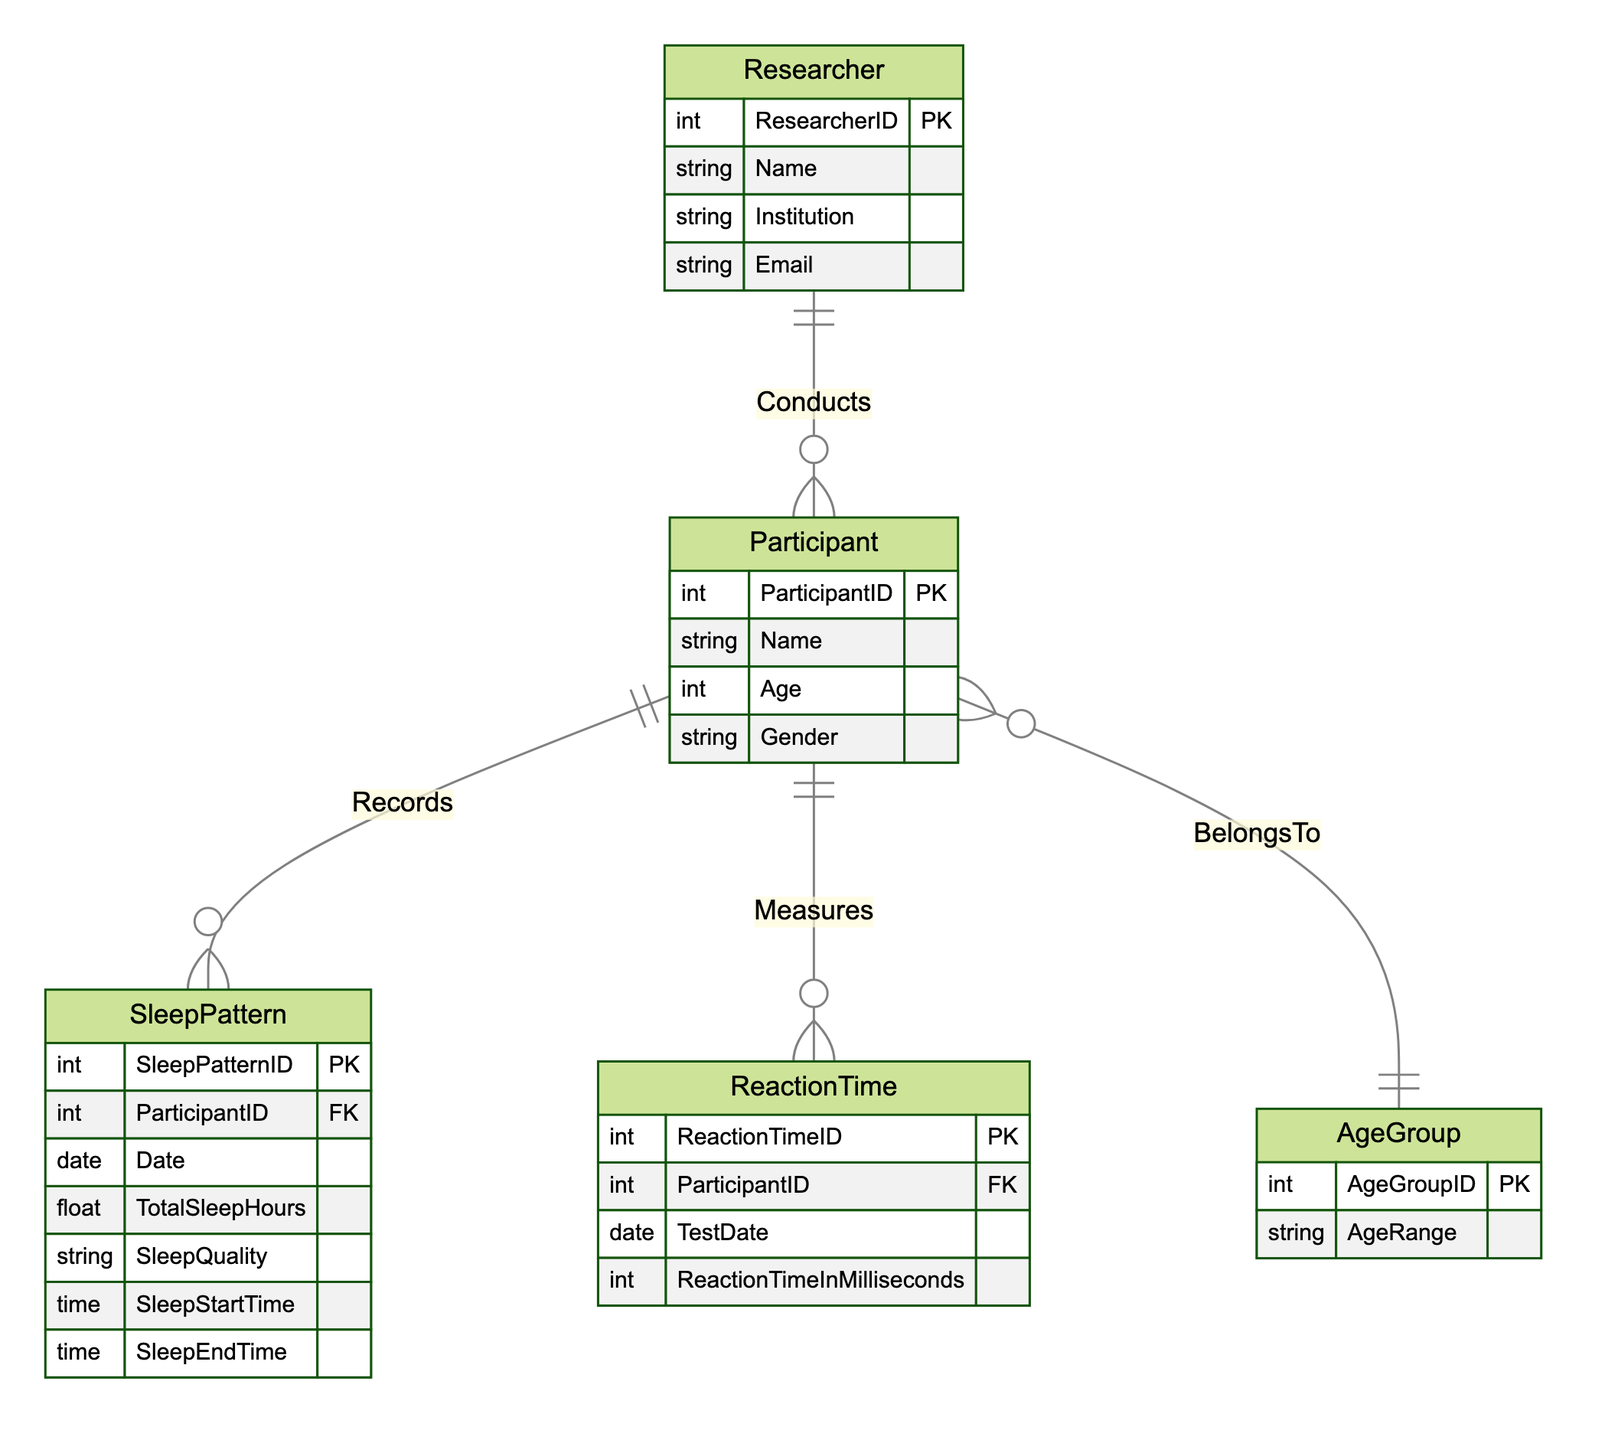What are the attributes of the SleepPattern entity? The SleepPattern entity includes the following attributes: SleepPatternID, ParticipantID, Date, TotalSleepHours, SleepQuality, SleepStartTime, and SleepEndTime.
Answer: SleepPatternID, ParticipantID, Date, TotalSleepHours, SleepQuality, SleepStartTime, SleepEndTime How many entities are there in the diagram? The diagram contains five entities: Researcher, Participant, SleepPattern, ReactionTime, and AgeGroup.
Answer: Five What relationship exists between Participant and AgeGroup? The relationship is called "BelongsTo", indicating that each participant is associated with a specific age group.
Answer: BelongsTo What is the foreign key in the SleepPattern entity? The foreign key in the SleepPattern entity is ParticipantID, which links the SleepPattern to the Participant entity.
Answer: ParticipantID How many relationships are listed in the diagram? There are four relationships in the diagram: Conducts, Records, Measures, and BelongsTo.
Answer: Four In which entity would you find the attribute "ReactionTimeInMilliseconds"? The attribute "ReactionTimeInMilliseconds" is found in the ReactionTime entity.
Answer: ReactionTime What is the primary key of the Participant entity? The primary key of the Participant entity is ParticipantID, which uniquely identifies each participant in the study.
Answer: ParticipantID Which entity contains data about total sleep hours? The SleepPattern entity contains data about total sleep hours, indicated by the attribute TotalSleepHours.
Answer: SleepPattern How many attributes does the Researcher entity have? The Researcher entity has four attributes: ResearcherID, Name, Institution, and Email.
Answer: Four 